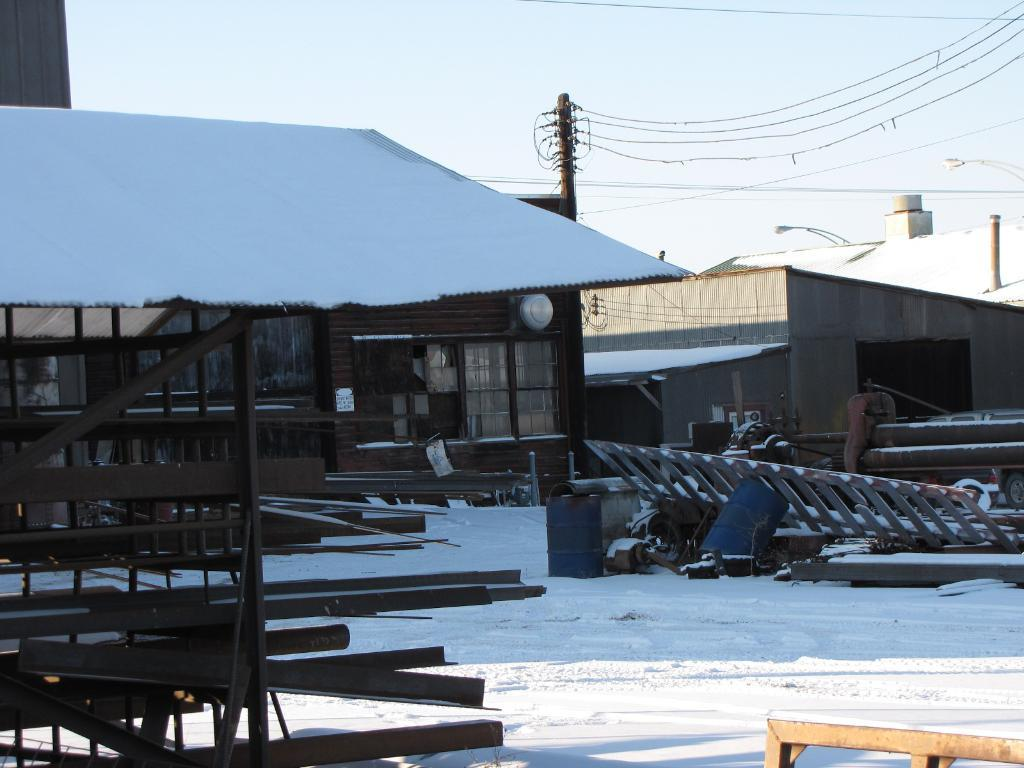What type of structures can be seen in the image? There are buildings in the image. What other objects are present in the image? There are poles, cables, lights, and metal rods in the image. What is the weather like in the image? There is snow visible in the image, indicating a cold or wintry environment. Where is the vehicle located in the image? The vehicle is on the right side of the image. Can you tell me how many flowers are blooming in the image? There are no flowers present in the image. Is there any blood visible on the vehicle in the image? There is no blood visible in the image. 